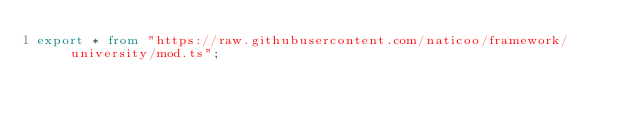Convert code to text. <code><loc_0><loc_0><loc_500><loc_500><_TypeScript_>export * from "https://raw.githubusercontent.com/naticoo/framework/university/mod.ts";
</code> 